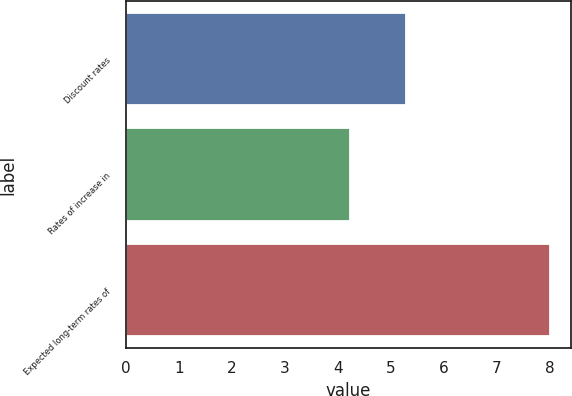Convert chart. <chart><loc_0><loc_0><loc_500><loc_500><bar_chart><fcel>Discount rates<fcel>Rates of increase in<fcel>Expected long-term rates of<nl><fcel>5.28<fcel>4.22<fcel>8<nl></chart> 